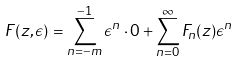<formula> <loc_0><loc_0><loc_500><loc_500>F ( z , \epsilon ) = \sum _ { n = - m } ^ { - 1 } \epsilon ^ { n } \cdot 0 + \sum _ { n = 0 } ^ { \infty } F _ { n } ( z ) \epsilon ^ { n }</formula> 